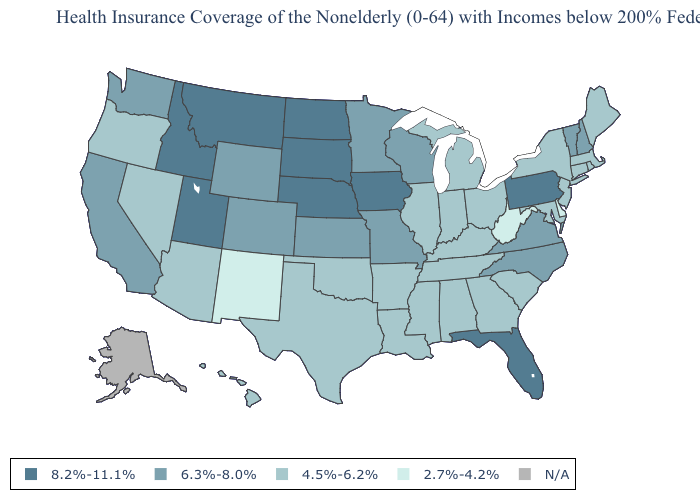What is the highest value in the USA?
Write a very short answer. 8.2%-11.1%. What is the lowest value in the USA?
Answer briefly. 2.7%-4.2%. What is the highest value in states that border Montana?
Quick response, please. 8.2%-11.1%. What is the value of Wyoming?
Give a very brief answer. 6.3%-8.0%. Name the states that have a value in the range 6.3%-8.0%?
Short answer required. California, Colorado, Kansas, Minnesota, Missouri, New Hampshire, North Carolina, Vermont, Virginia, Washington, Wisconsin, Wyoming. Does the map have missing data?
Short answer required. Yes. Which states have the lowest value in the USA?
Be succinct. Delaware, New Mexico, West Virginia. What is the value of New York?
Write a very short answer. 4.5%-6.2%. What is the lowest value in the West?
Quick response, please. 2.7%-4.2%. What is the highest value in the USA?
Short answer required. 8.2%-11.1%. How many symbols are there in the legend?
Be succinct. 5. What is the value of Alabama?
Short answer required. 4.5%-6.2%. Name the states that have a value in the range N/A?
Write a very short answer. Alaska. 